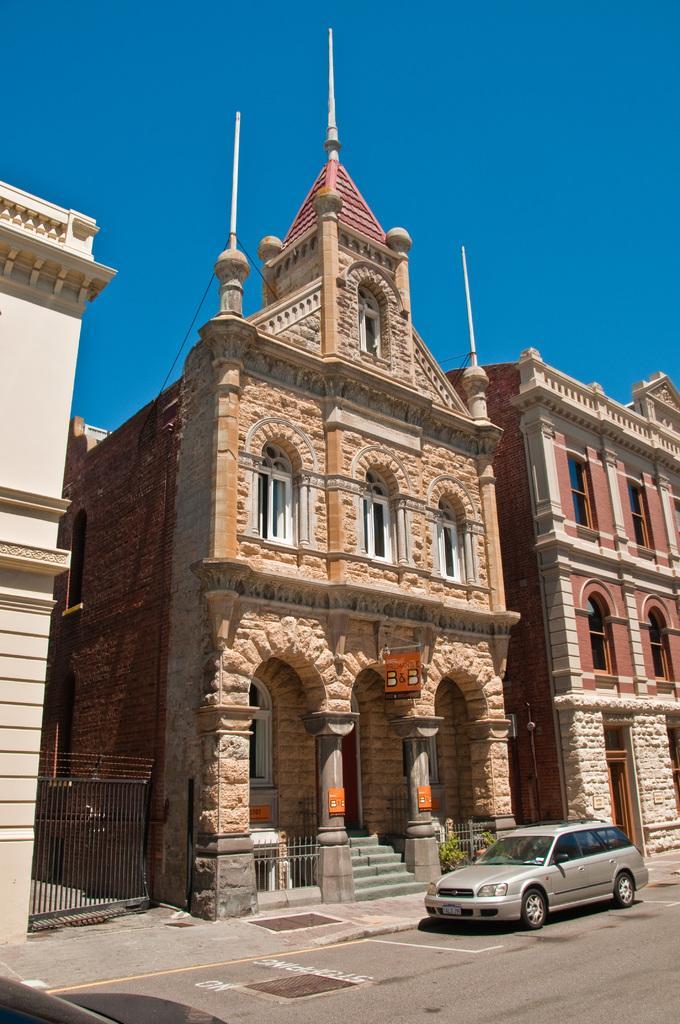In one or two sentences, can you explain what this image depicts? This picture is clicked outside the city. At the bottom of the picture, we see the road and we see the car parked on the road. Beside that, we see the staircase and an iron railing. Beside that, we see the buildings. At the top, we see the sky, which is blue in color and it is a sunny day. 